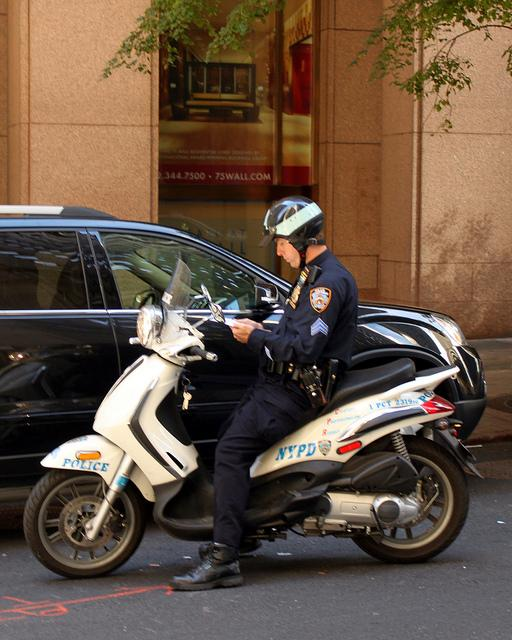Who is on the bicycle? Please explain your reasoning. police officer. There is a police officer in uniform sitting on the motorcycle. 